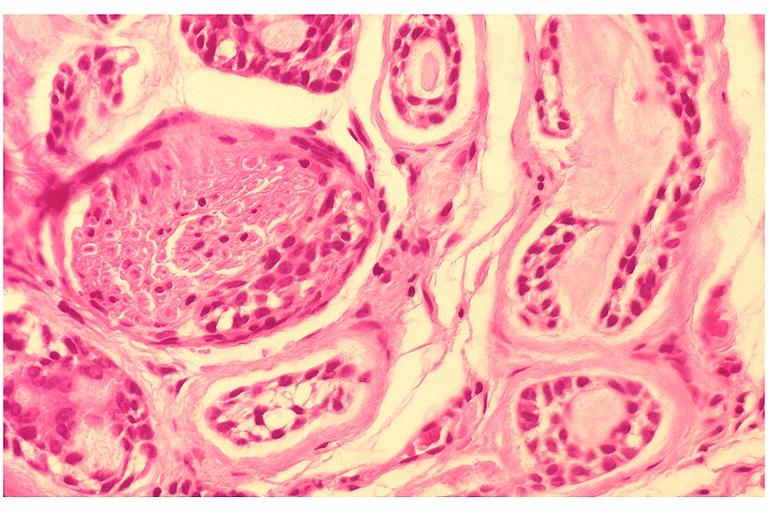what does this image show?
Answer the question using a single word or phrase. Adenoid cystic carcinoma 